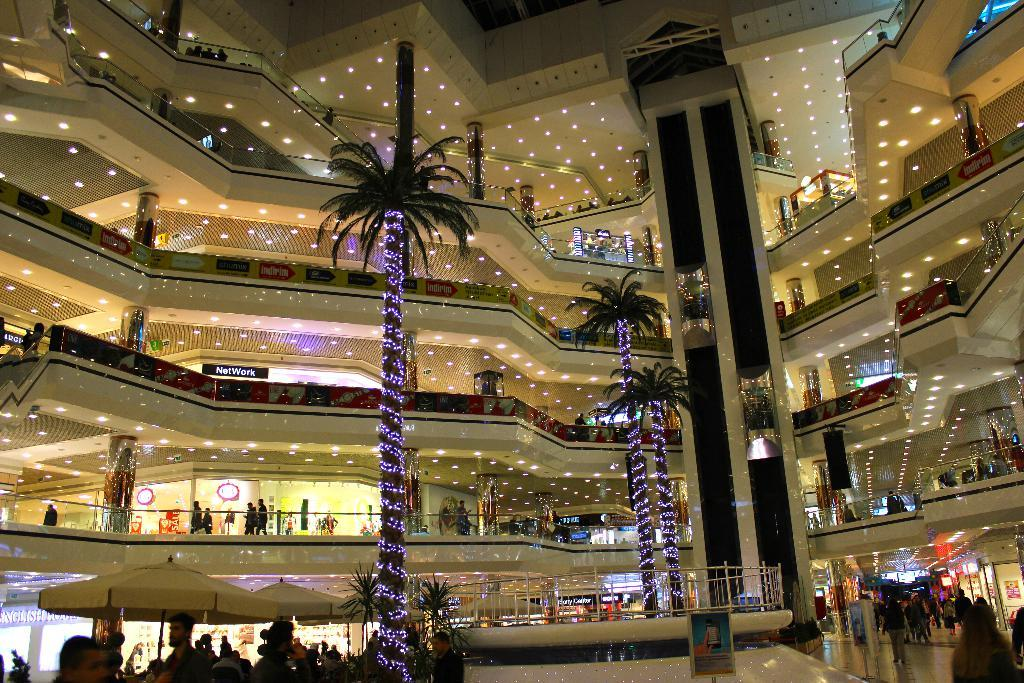What type of location is depicted in the image? The image is an inside view of a shopping complex. What type of vegetation can be seen in the shopping complex? There are trees in the shopping complex. What type of shelter is available for shoppers in the shopping complex? There are umbrellas with poles in the shopping complex. How can shoppers move between floors in the shopping complex? Passenger lifts are present in the shopping complex. How can shoppers identify specific stores or areas in the shopping complex? Name boards are visible in the shopping complex. What type of establishments are present in the shopping complex? Stalls are present in the shopping complex. What type of lighting is present in the shopping complex? Lights are visible in the shopping complex. How are promotions or advertisements displayed in the shopping complex? Light boards are present in the shopping complex. Are there any people present in the shopping complex? Yes, there is a group of people in the shopping complex. What is the world record for the longest shopping spree in the shopping complex? There is no information about any world records in the image, and the image does not provide enough context to determine such a record. 